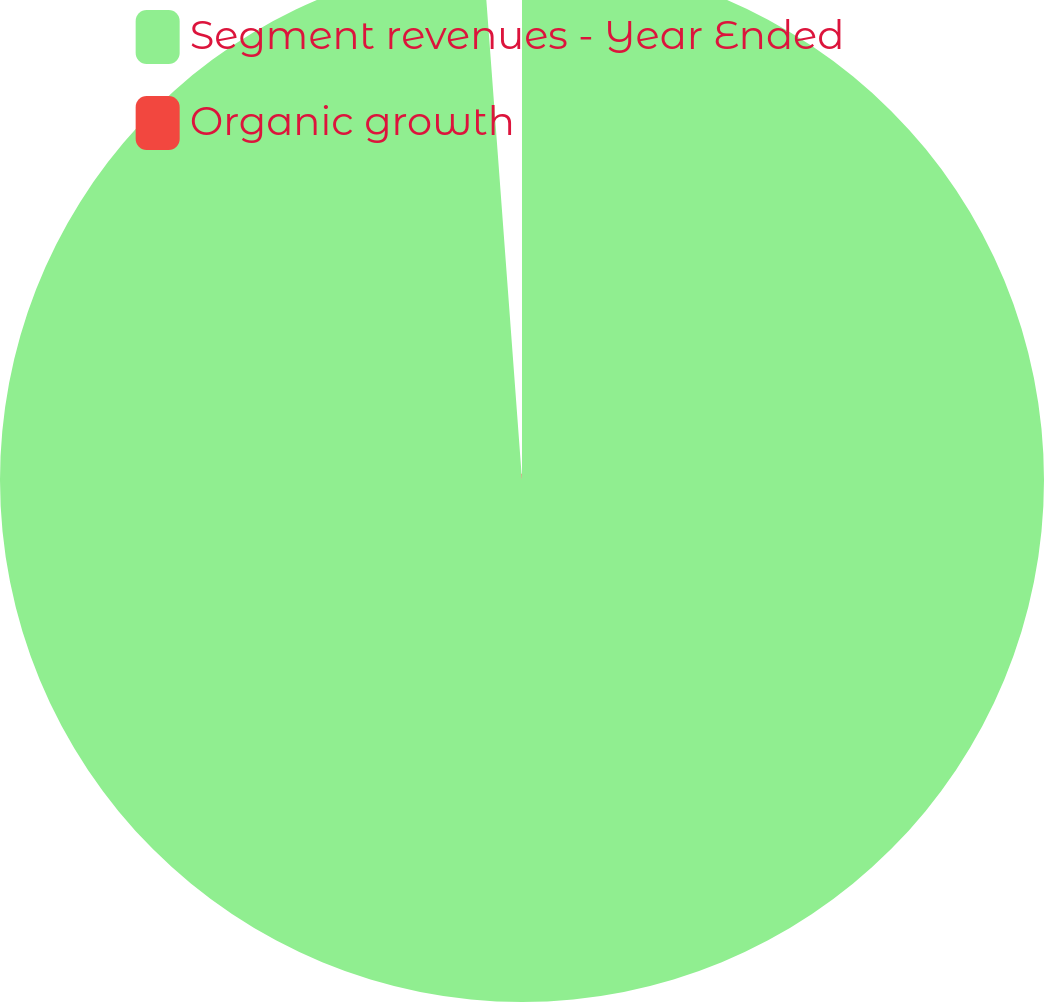Convert chart. <chart><loc_0><loc_0><loc_500><loc_500><pie_chart><fcel>Segment revenues - Year Ended<fcel>Organic growth<nl><fcel>98.82%<fcel>1.18%<nl></chart> 